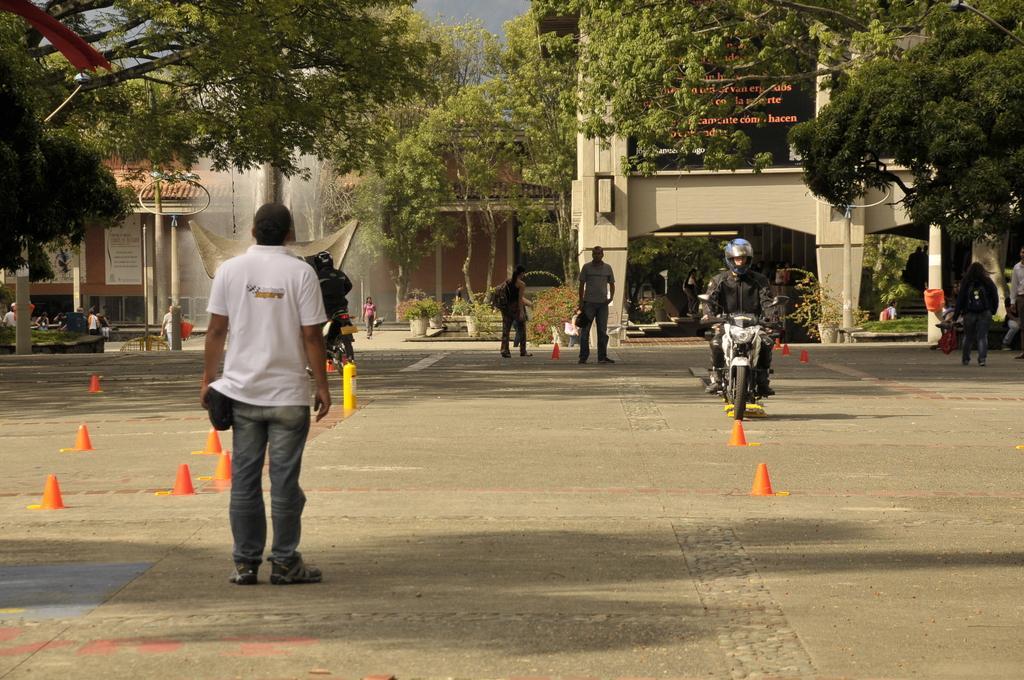Please provide a concise description of this image. In this image I can see some people. I can see the vehicles on the road. In the background, I can see the trees and the buildings with some text written on it. 